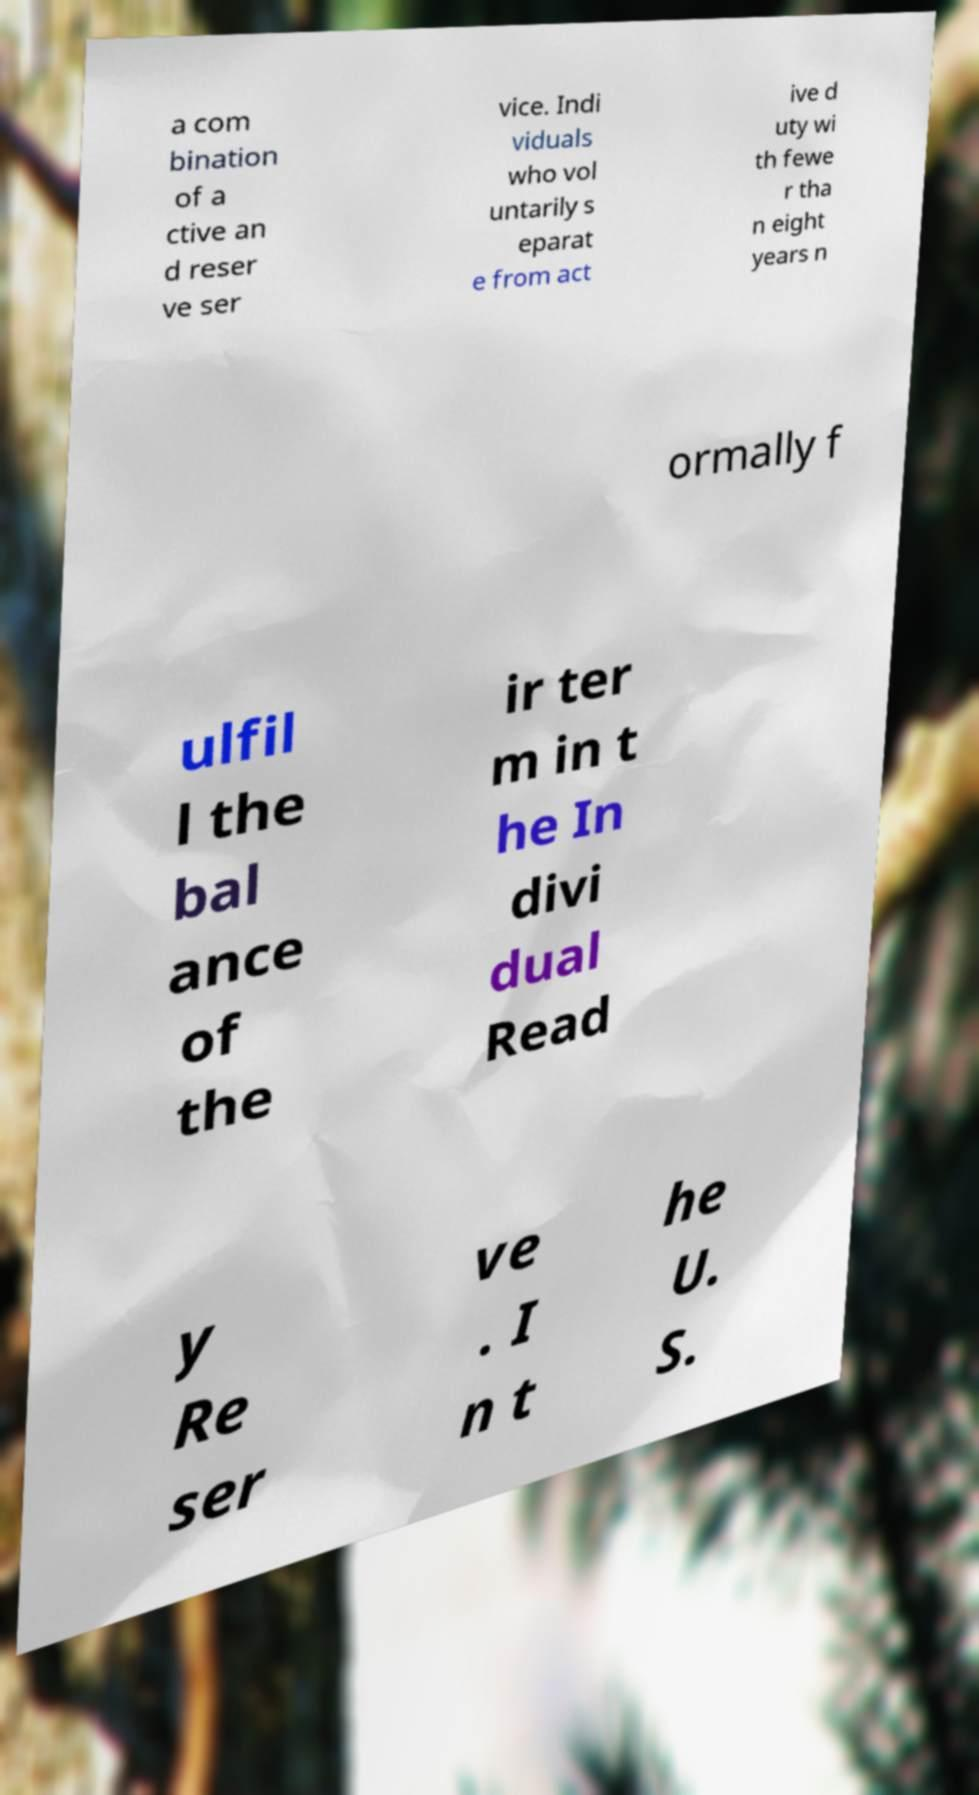Can you accurately transcribe the text from the provided image for me? a com bination of a ctive an d reser ve ser vice. Indi viduals who vol untarily s eparat e from act ive d uty wi th fewe r tha n eight years n ormally f ulfil l the bal ance of the ir ter m in t he In divi dual Read y Re ser ve . I n t he U. S. 